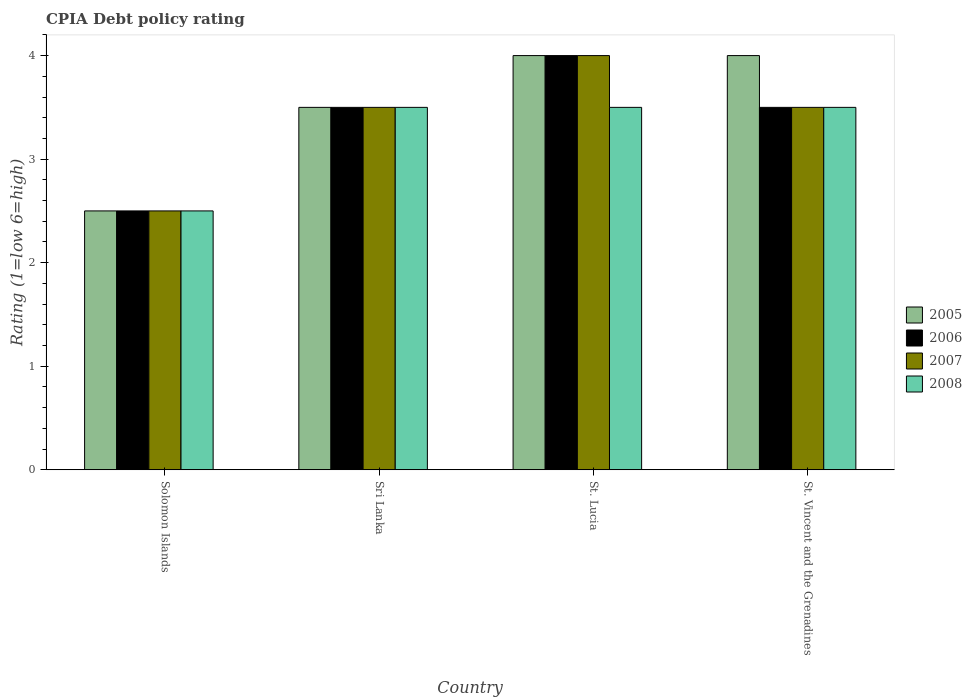How many different coloured bars are there?
Give a very brief answer. 4. How many groups of bars are there?
Provide a succinct answer. 4. Are the number of bars on each tick of the X-axis equal?
Your answer should be compact. Yes. How many bars are there on the 3rd tick from the left?
Ensure brevity in your answer.  4. How many bars are there on the 4th tick from the right?
Your response must be concise. 4. What is the label of the 4th group of bars from the left?
Ensure brevity in your answer.  St. Vincent and the Grenadines. What is the CPIA rating in 2006 in St. Lucia?
Your response must be concise. 4. Across all countries, what is the maximum CPIA rating in 2007?
Your answer should be very brief. 4. In which country was the CPIA rating in 2006 maximum?
Your answer should be very brief. St. Lucia. In which country was the CPIA rating in 2007 minimum?
Provide a succinct answer. Solomon Islands. What is the difference between the CPIA rating in 2006 in Sri Lanka and that in St. Vincent and the Grenadines?
Make the answer very short. 0. What is the average CPIA rating in 2006 per country?
Make the answer very short. 3.38. What is the difference between the CPIA rating of/in 2006 and CPIA rating of/in 2005 in Solomon Islands?
Offer a very short reply. 0. In how many countries, is the CPIA rating in 2007 greater than 1.6?
Your answer should be compact. 4. Is the CPIA rating in 2006 in Sri Lanka less than that in St. Lucia?
Give a very brief answer. Yes. Is the difference between the CPIA rating in 2006 in Sri Lanka and St. Vincent and the Grenadines greater than the difference between the CPIA rating in 2005 in Sri Lanka and St. Vincent and the Grenadines?
Provide a succinct answer. Yes. What is the difference between the highest and the second highest CPIA rating in 2007?
Give a very brief answer. -0.5. What is the difference between the highest and the lowest CPIA rating in 2007?
Your response must be concise. 1.5. In how many countries, is the CPIA rating in 2007 greater than the average CPIA rating in 2007 taken over all countries?
Your response must be concise. 3. Is the sum of the CPIA rating in 2005 in Sri Lanka and St. Vincent and the Grenadines greater than the maximum CPIA rating in 2008 across all countries?
Keep it short and to the point. Yes. Is it the case that in every country, the sum of the CPIA rating in 2006 and CPIA rating in 2005 is greater than the sum of CPIA rating in 2008 and CPIA rating in 2007?
Offer a terse response. No. What does the 2nd bar from the left in St. Lucia represents?
Provide a succinct answer. 2006. What is the difference between two consecutive major ticks on the Y-axis?
Keep it short and to the point. 1. Does the graph contain any zero values?
Your answer should be compact. No. Does the graph contain grids?
Offer a very short reply. No. Where does the legend appear in the graph?
Your answer should be very brief. Center right. How many legend labels are there?
Make the answer very short. 4. What is the title of the graph?
Your response must be concise. CPIA Debt policy rating. Does "1962" appear as one of the legend labels in the graph?
Ensure brevity in your answer.  No. What is the label or title of the X-axis?
Give a very brief answer. Country. What is the label or title of the Y-axis?
Keep it short and to the point. Rating (1=low 6=high). What is the Rating (1=low 6=high) in 2006 in Solomon Islands?
Provide a short and direct response. 2.5. What is the Rating (1=low 6=high) in 2007 in Solomon Islands?
Your answer should be compact. 2.5. What is the Rating (1=low 6=high) of 2005 in Sri Lanka?
Your answer should be very brief. 3.5. What is the Rating (1=low 6=high) in 2006 in Sri Lanka?
Offer a terse response. 3.5. What is the Rating (1=low 6=high) of 2005 in St. Lucia?
Make the answer very short. 4. What is the Rating (1=low 6=high) of 2006 in St. Lucia?
Give a very brief answer. 4. What is the Rating (1=low 6=high) in 2007 in St. Lucia?
Make the answer very short. 4. What is the Rating (1=low 6=high) of 2008 in St. Lucia?
Make the answer very short. 3.5. What is the Rating (1=low 6=high) in 2006 in St. Vincent and the Grenadines?
Keep it short and to the point. 3.5. What is the Rating (1=low 6=high) of 2008 in St. Vincent and the Grenadines?
Provide a succinct answer. 3.5. Across all countries, what is the minimum Rating (1=low 6=high) in 2007?
Give a very brief answer. 2.5. Across all countries, what is the minimum Rating (1=low 6=high) of 2008?
Provide a succinct answer. 2.5. What is the total Rating (1=low 6=high) in 2005 in the graph?
Offer a very short reply. 14. What is the total Rating (1=low 6=high) of 2007 in the graph?
Keep it short and to the point. 13.5. What is the difference between the Rating (1=low 6=high) in 2007 in Solomon Islands and that in Sri Lanka?
Your response must be concise. -1. What is the difference between the Rating (1=low 6=high) in 2008 in Solomon Islands and that in Sri Lanka?
Your answer should be very brief. -1. What is the difference between the Rating (1=low 6=high) of 2005 in Solomon Islands and that in St. Lucia?
Your answer should be very brief. -1.5. What is the difference between the Rating (1=low 6=high) in 2005 in Solomon Islands and that in St. Vincent and the Grenadines?
Give a very brief answer. -1.5. What is the difference between the Rating (1=low 6=high) of 2006 in Solomon Islands and that in St. Vincent and the Grenadines?
Offer a terse response. -1. What is the difference between the Rating (1=low 6=high) of 2007 in Solomon Islands and that in St. Vincent and the Grenadines?
Provide a short and direct response. -1. What is the difference between the Rating (1=low 6=high) in 2006 in Sri Lanka and that in St. Lucia?
Offer a very short reply. -0.5. What is the difference between the Rating (1=low 6=high) of 2007 in Sri Lanka and that in St. Lucia?
Offer a terse response. -0.5. What is the difference between the Rating (1=low 6=high) in 2008 in Sri Lanka and that in St. Lucia?
Ensure brevity in your answer.  0. What is the difference between the Rating (1=low 6=high) in 2005 in Sri Lanka and that in St. Vincent and the Grenadines?
Provide a succinct answer. -0.5. What is the difference between the Rating (1=low 6=high) of 2007 in Sri Lanka and that in St. Vincent and the Grenadines?
Provide a short and direct response. 0. What is the difference between the Rating (1=low 6=high) in 2008 in Sri Lanka and that in St. Vincent and the Grenadines?
Make the answer very short. 0. What is the difference between the Rating (1=low 6=high) in 2006 in St. Lucia and that in St. Vincent and the Grenadines?
Provide a succinct answer. 0.5. What is the difference between the Rating (1=low 6=high) of 2007 in St. Lucia and that in St. Vincent and the Grenadines?
Keep it short and to the point. 0.5. What is the difference between the Rating (1=low 6=high) of 2008 in St. Lucia and that in St. Vincent and the Grenadines?
Your answer should be compact. 0. What is the difference between the Rating (1=low 6=high) in 2005 in Solomon Islands and the Rating (1=low 6=high) in 2007 in Sri Lanka?
Keep it short and to the point. -1. What is the difference between the Rating (1=low 6=high) in 2005 in Solomon Islands and the Rating (1=low 6=high) in 2008 in Sri Lanka?
Provide a succinct answer. -1. What is the difference between the Rating (1=low 6=high) of 2007 in Solomon Islands and the Rating (1=low 6=high) of 2008 in Sri Lanka?
Make the answer very short. -1. What is the difference between the Rating (1=low 6=high) in 2005 in Solomon Islands and the Rating (1=low 6=high) in 2006 in St. Lucia?
Ensure brevity in your answer.  -1.5. What is the difference between the Rating (1=low 6=high) in 2005 in Solomon Islands and the Rating (1=low 6=high) in 2008 in St. Lucia?
Your answer should be compact. -1. What is the difference between the Rating (1=low 6=high) of 2007 in Solomon Islands and the Rating (1=low 6=high) of 2008 in St. Lucia?
Your response must be concise. -1. What is the difference between the Rating (1=low 6=high) in 2005 in Solomon Islands and the Rating (1=low 6=high) in 2007 in St. Vincent and the Grenadines?
Give a very brief answer. -1. What is the difference between the Rating (1=low 6=high) of 2006 in Solomon Islands and the Rating (1=low 6=high) of 2007 in St. Vincent and the Grenadines?
Your answer should be very brief. -1. What is the difference between the Rating (1=low 6=high) of 2005 in Sri Lanka and the Rating (1=low 6=high) of 2008 in St. Lucia?
Provide a succinct answer. 0. What is the difference between the Rating (1=low 6=high) in 2006 in Sri Lanka and the Rating (1=low 6=high) in 2007 in St. Lucia?
Provide a succinct answer. -0.5. What is the difference between the Rating (1=low 6=high) of 2006 in Sri Lanka and the Rating (1=low 6=high) of 2008 in St. Lucia?
Provide a succinct answer. 0. What is the difference between the Rating (1=low 6=high) of 2005 in Sri Lanka and the Rating (1=low 6=high) of 2007 in St. Vincent and the Grenadines?
Your answer should be compact. 0. What is the difference between the Rating (1=low 6=high) in 2006 in Sri Lanka and the Rating (1=low 6=high) in 2007 in St. Vincent and the Grenadines?
Your answer should be compact. 0. What is the difference between the Rating (1=low 6=high) in 2006 in Sri Lanka and the Rating (1=low 6=high) in 2008 in St. Vincent and the Grenadines?
Ensure brevity in your answer.  0. What is the difference between the Rating (1=low 6=high) in 2007 in Sri Lanka and the Rating (1=low 6=high) in 2008 in St. Vincent and the Grenadines?
Provide a short and direct response. 0. What is the difference between the Rating (1=low 6=high) in 2005 in St. Lucia and the Rating (1=low 6=high) in 2006 in St. Vincent and the Grenadines?
Provide a short and direct response. 0.5. What is the difference between the Rating (1=low 6=high) in 2005 in St. Lucia and the Rating (1=low 6=high) in 2007 in St. Vincent and the Grenadines?
Provide a short and direct response. 0.5. What is the difference between the Rating (1=low 6=high) of 2005 in St. Lucia and the Rating (1=low 6=high) of 2008 in St. Vincent and the Grenadines?
Your answer should be very brief. 0.5. What is the difference between the Rating (1=low 6=high) in 2006 in St. Lucia and the Rating (1=low 6=high) in 2007 in St. Vincent and the Grenadines?
Provide a short and direct response. 0.5. What is the difference between the Rating (1=low 6=high) in 2007 in St. Lucia and the Rating (1=low 6=high) in 2008 in St. Vincent and the Grenadines?
Your answer should be very brief. 0.5. What is the average Rating (1=low 6=high) of 2005 per country?
Your answer should be compact. 3.5. What is the average Rating (1=low 6=high) of 2006 per country?
Your response must be concise. 3.38. What is the average Rating (1=low 6=high) in 2007 per country?
Make the answer very short. 3.38. What is the difference between the Rating (1=low 6=high) in 2005 and Rating (1=low 6=high) in 2006 in Solomon Islands?
Your response must be concise. 0. What is the difference between the Rating (1=low 6=high) of 2005 and Rating (1=low 6=high) of 2007 in Solomon Islands?
Provide a succinct answer. 0. What is the difference between the Rating (1=low 6=high) of 2005 and Rating (1=low 6=high) of 2007 in Sri Lanka?
Provide a succinct answer. 0. What is the difference between the Rating (1=low 6=high) in 2006 and Rating (1=low 6=high) in 2008 in Sri Lanka?
Your answer should be compact. 0. What is the difference between the Rating (1=low 6=high) in 2005 and Rating (1=low 6=high) in 2006 in St. Lucia?
Keep it short and to the point. 0. What is the difference between the Rating (1=low 6=high) in 2005 and Rating (1=low 6=high) in 2007 in St. Lucia?
Give a very brief answer. 0. What is the difference between the Rating (1=low 6=high) of 2006 and Rating (1=low 6=high) of 2007 in St. Lucia?
Offer a very short reply. 0. What is the difference between the Rating (1=low 6=high) in 2005 and Rating (1=low 6=high) in 2006 in St. Vincent and the Grenadines?
Offer a very short reply. 0.5. What is the difference between the Rating (1=low 6=high) of 2005 and Rating (1=low 6=high) of 2007 in St. Vincent and the Grenadines?
Make the answer very short. 0.5. What is the difference between the Rating (1=low 6=high) in 2006 and Rating (1=low 6=high) in 2007 in St. Vincent and the Grenadines?
Provide a short and direct response. 0. What is the difference between the Rating (1=low 6=high) in 2006 and Rating (1=low 6=high) in 2008 in St. Vincent and the Grenadines?
Provide a succinct answer. 0. What is the difference between the Rating (1=low 6=high) of 2007 and Rating (1=low 6=high) of 2008 in St. Vincent and the Grenadines?
Your answer should be very brief. 0. What is the ratio of the Rating (1=low 6=high) in 2005 in Solomon Islands to that in Sri Lanka?
Keep it short and to the point. 0.71. What is the ratio of the Rating (1=low 6=high) of 2007 in Solomon Islands to that in Sri Lanka?
Your response must be concise. 0.71. What is the ratio of the Rating (1=low 6=high) in 2008 in Solomon Islands to that in Sri Lanka?
Provide a short and direct response. 0.71. What is the ratio of the Rating (1=low 6=high) of 2005 in Solomon Islands to that in St. Lucia?
Your answer should be compact. 0.62. What is the ratio of the Rating (1=low 6=high) in 2007 in Solomon Islands to that in St. Lucia?
Provide a short and direct response. 0.62. What is the ratio of the Rating (1=low 6=high) in 2005 in Solomon Islands to that in St. Vincent and the Grenadines?
Offer a very short reply. 0.62. What is the ratio of the Rating (1=low 6=high) of 2007 in Solomon Islands to that in St. Vincent and the Grenadines?
Make the answer very short. 0.71. What is the ratio of the Rating (1=low 6=high) in 2008 in Solomon Islands to that in St. Vincent and the Grenadines?
Your response must be concise. 0.71. What is the ratio of the Rating (1=low 6=high) in 2005 in Sri Lanka to that in St. Lucia?
Your answer should be compact. 0.88. What is the ratio of the Rating (1=low 6=high) in 2006 in Sri Lanka to that in St. Lucia?
Offer a very short reply. 0.88. What is the ratio of the Rating (1=low 6=high) of 2007 in Sri Lanka to that in St. Lucia?
Your answer should be compact. 0.88. What is the ratio of the Rating (1=low 6=high) of 2006 in St. Lucia to that in St. Vincent and the Grenadines?
Offer a terse response. 1.14. What is the difference between the highest and the second highest Rating (1=low 6=high) in 2005?
Ensure brevity in your answer.  0. What is the difference between the highest and the second highest Rating (1=low 6=high) in 2006?
Your response must be concise. 0.5. What is the difference between the highest and the lowest Rating (1=low 6=high) in 2005?
Your answer should be very brief. 1.5. What is the difference between the highest and the lowest Rating (1=low 6=high) in 2006?
Your answer should be very brief. 1.5. What is the difference between the highest and the lowest Rating (1=low 6=high) of 2007?
Provide a short and direct response. 1.5. What is the difference between the highest and the lowest Rating (1=low 6=high) of 2008?
Give a very brief answer. 1. 